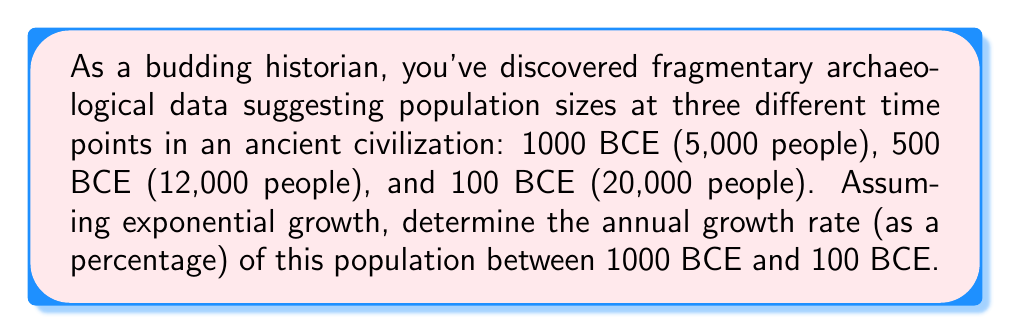Teach me how to tackle this problem. To solve this problem, we'll use the exponential growth formula and the given data points. Let's approach this step-by-step:

1) The exponential growth formula is:
   $$P(t) = P_0 e^{rt}$$
   where $P(t)$ is the population at time $t$, $P_0$ is the initial population, $r$ is the growth rate, and $t$ is the time elapsed.

2) We have two data points to use: 1000 BCE (initial) and 100 BCE (final). Let's set up the equation:
   $$20000 = 5000 e^{900r}$$

3) Divide both sides by 5000:
   $$4 = e^{900r}$$

4) Take the natural log of both sides:
   $$\ln(4) = 900r$$

5) Solve for $r$:
   $$r = \frac{\ln(4)}{900} \approx 0.001535$$

6) To convert this to a percentage, multiply by 100:
   $$0.001535 * 100 \approx 0.1535\%$$

This represents the average annual growth rate over the 900-year period.
Answer: 0.1535% 